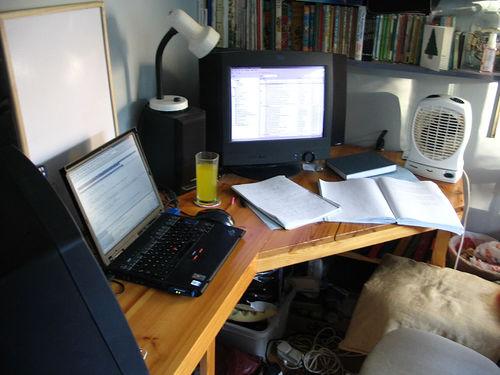What is in the glass?
Be succinct. Orange juice. What holiday is the card in the upper right celebrating?
Quick response, please. Christmas. What is the purpose of a dual-monitor setup?
Concise answer only. Production. 